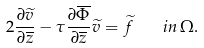Convert formula to latex. <formula><loc_0><loc_0><loc_500><loc_500>2 \frac { \partial \widetilde { v } } { \partial \overline { z } } - \tau \frac { \partial \overline { \Phi } } { \partial \overline { z } } \widetilde { v } = \widetilde { f } \quad i n \, \Omega .</formula> 